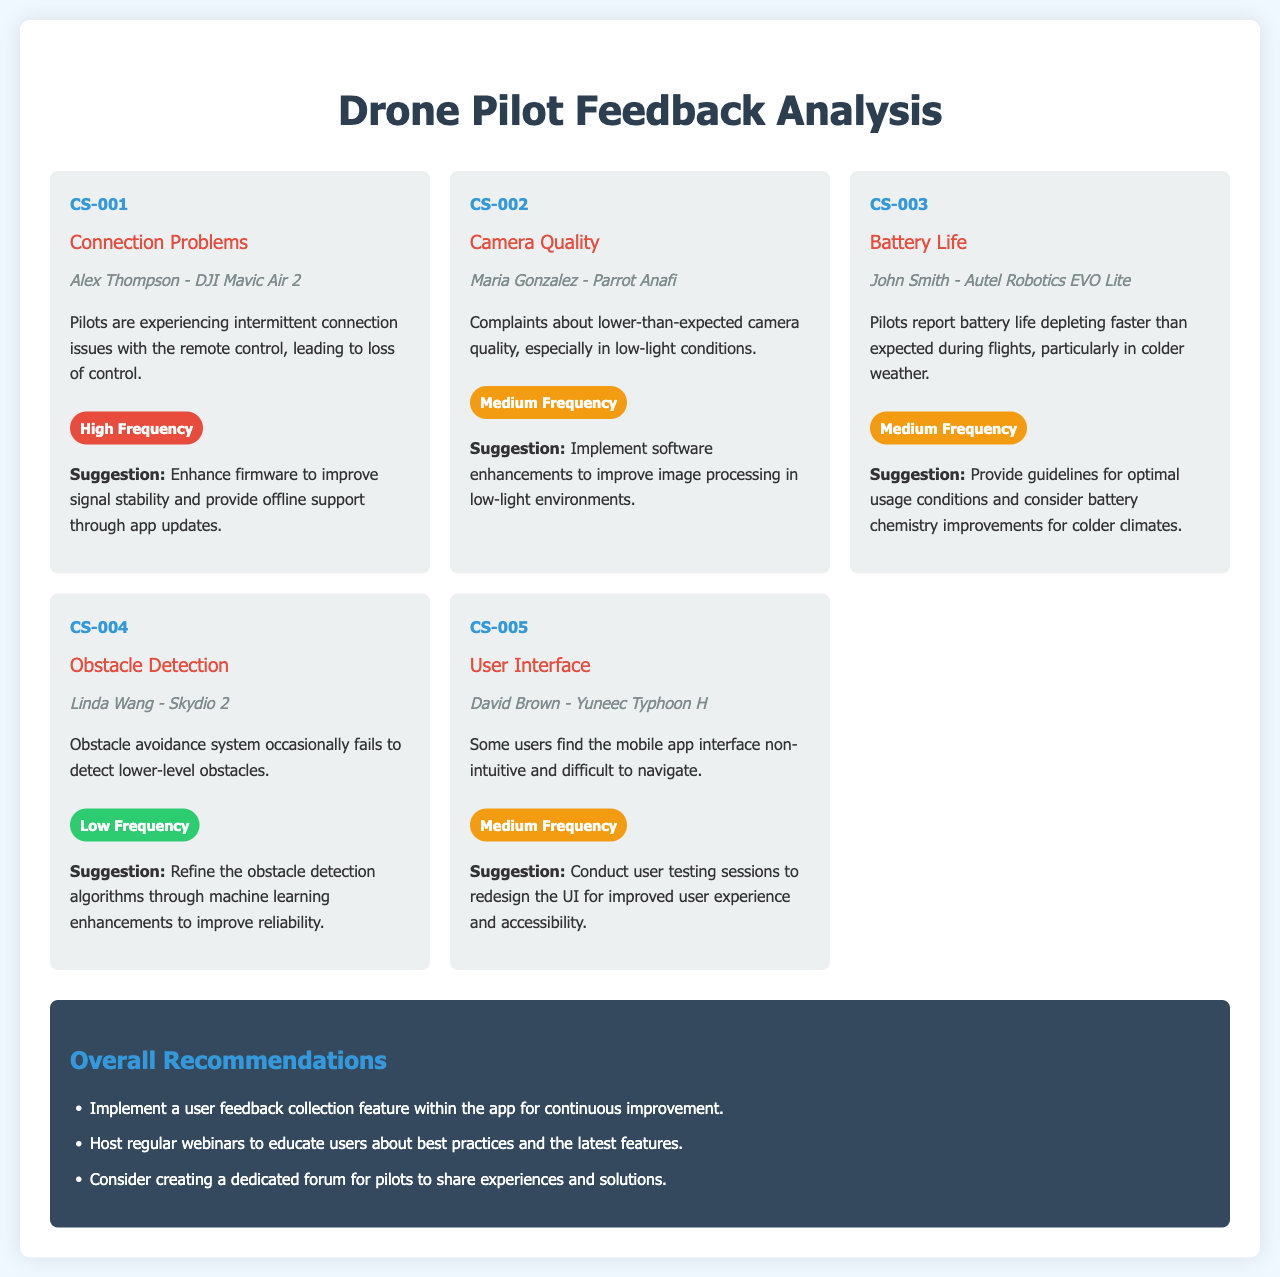What is the first issue listed in the document? The first issue listed is "Connection Problems," as shown in the first issue card.
Answer: Connection Problems Who reported issues with camera quality? Maria Gonzalez is the pilot who reported concerns about camera quality in the document.
Answer: Maria Gonzalez How many medium frequency issues are mentioned? There are three issues identified as medium frequency in the document.
Answer: 3 What suggestion was made to improve battery life? The suggestion is to provide guidelines for optimal usage conditions and consider battery chemistry improvements.
Answer: Provide guidelines for optimal usage conditions and consider battery chemistry improvements What is the name of the pilot associated with the obstacle detection issue? The pilot associated with the obstacle detection issue is Linda Wang, as specified in the issue card.
Answer: Linda Wang Which issue has a high frequency of reports? The issue with "Connection Problems" has a high frequency, indicating it is widely reported by pilots.
Answer: Connection Problems What overall recommendation is given to enhance user experience? One of the overall recommendations is to implement a user feedback collection feature within the app.
Answer: Implement a user feedback collection feature within the app What type of drone does David Brown fly? David Brown flies the Yuneec Typhoon H, which is mentioned in the context of the user interface issue.
Answer: Yuneec Typhoon H 